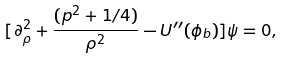<formula> <loc_0><loc_0><loc_500><loc_500>[ \partial _ { \rho } ^ { 2 } + \frac { ( p ^ { 2 } + 1 / 4 ) } { \rho ^ { 2 } } - U ^ { \prime \prime } ( \phi _ { b } ) ] \psi = 0 ,</formula> 